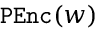<formula> <loc_0><loc_0><loc_500><loc_500>P E n c ( w )</formula> 